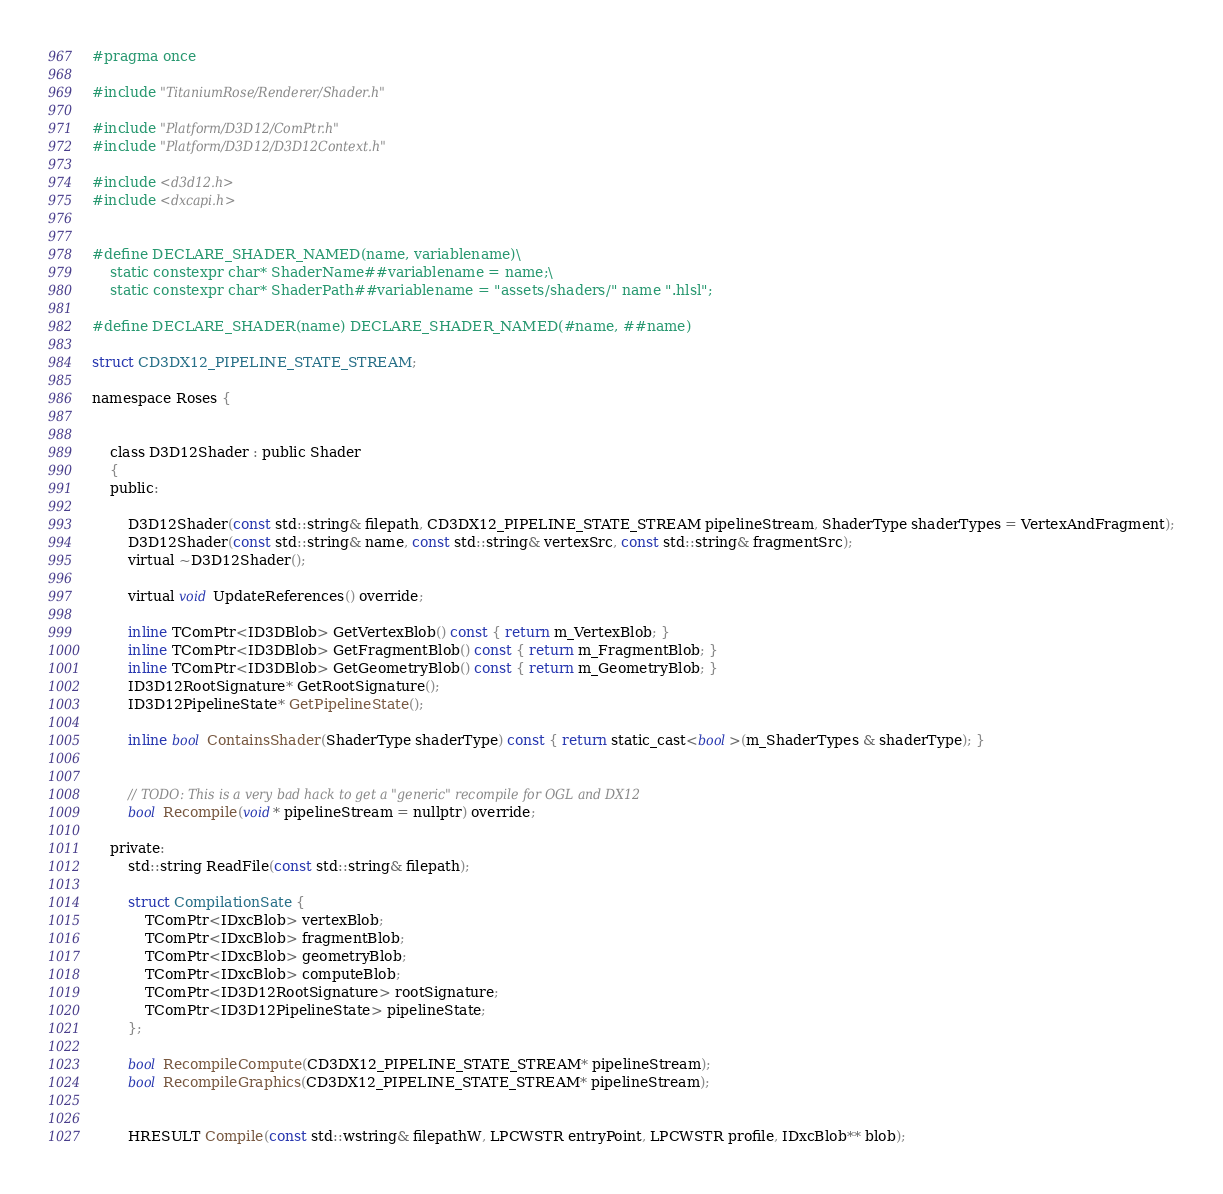<code> <loc_0><loc_0><loc_500><loc_500><_C_>#pragma once

#include "TitaniumRose/Renderer/Shader.h"

#include "Platform/D3D12/ComPtr.h"
#include "Platform/D3D12/D3D12Context.h"

#include <d3d12.h>
#include <dxcapi.h>


#define DECLARE_SHADER_NAMED(name, variablename)\
    static constexpr char* ShaderName##variablename = name;\
    static constexpr char* ShaderPath##variablename = "assets/shaders/" name ".hlsl";

#define DECLARE_SHADER(name) DECLARE_SHADER_NAMED(#name, ##name) 

struct CD3DX12_PIPELINE_STATE_STREAM;

namespace Roses {
	
	
	class D3D12Shader : public Shader
	{
	public:

		D3D12Shader(const std::string& filepath, CD3DX12_PIPELINE_STATE_STREAM pipelineStream, ShaderType shaderTypes = VertexAndFragment);
		D3D12Shader(const std::string& name, const std::string& vertexSrc, const std::string& fragmentSrc);
		virtual ~D3D12Shader();

		virtual void UpdateReferences() override;

		inline TComPtr<ID3DBlob> GetVertexBlob() const { return m_VertexBlob; }
		inline TComPtr<ID3DBlob> GetFragmentBlob() const { return m_FragmentBlob; }
		inline TComPtr<ID3DBlob> GetGeometryBlob() const { return m_GeometryBlob; }
		ID3D12RootSignature* GetRootSignature();
		ID3D12PipelineState* GetPipelineState();

		inline bool ContainsShader(ShaderType shaderType) const { return static_cast<bool>(m_ShaderTypes & shaderType); }


		// TODO: This is a very bad hack to get a "generic" recompile for OGL and DX12
		bool Recompile(void* pipelineStream = nullptr) override;
		
	private:
		std::string ReadFile(const std::string& filepath);

		struct CompilationSate {
			TComPtr<IDxcBlob> vertexBlob;
			TComPtr<IDxcBlob> fragmentBlob;
			TComPtr<IDxcBlob> geometryBlob;
			TComPtr<IDxcBlob> computeBlob;
			TComPtr<ID3D12RootSignature> rootSignature;
			TComPtr<ID3D12PipelineState> pipelineState;
		};

		bool RecompileCompute(CD3DX12_PIPELINE_STATE_STREAM* pipelineStream);
		bool RecompileGraphics(CD3DX12_PIPELINE_STATE_STREAM* pipelineStream);


		HRESULT Compile(const std::wstring& filepathW, LPCWSTR entryPoint, LPCWSTR profile, IDxcBlob** blob);</code> 